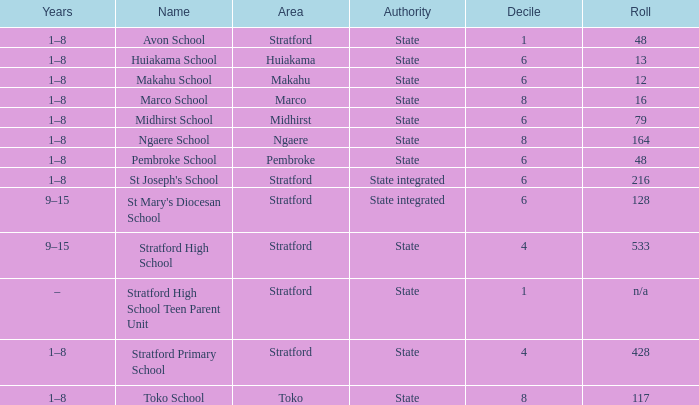What is the lowest decile with a state authority and Midhirst school? 6.0. 